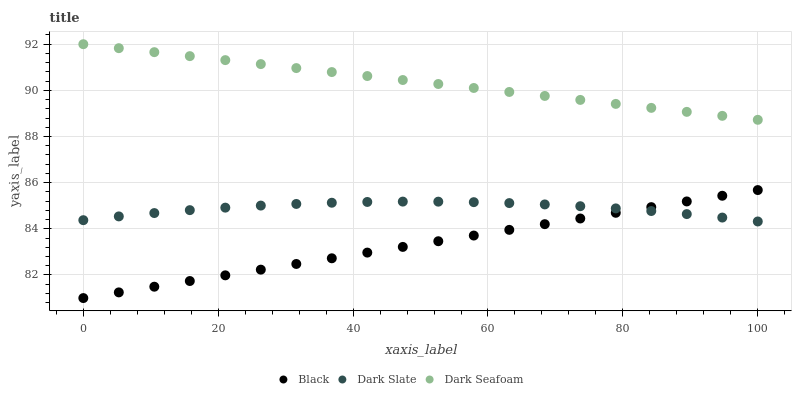Does Black have the minimum area under the curve?
Answer yes or no. Yes. Does Dark Seafoam have the maximum area under the curve?
Answer yes or no. Yes. Does Dark Seafoam have the minimum area under the curve?
Answer yes or no. No. Does Black have the maximum area under the curve?
Answer yes or no. No. Is Dark Seafoam the smoothest?
Answer yes or no. Yes. Is Dark Slate the roughest?
Answer yes or no. Yes. Is Black the smoothest?
Answer yes or no. No. Is Black the roughest?
Answer yes or no. No. Does Black have the lowest value?
Answer yes or no. Yes. Does Dark Seafoam have the lowest value?
Answer yes or no. No. Does Dark Seafoam have the highest value?
Answer yes or no. Yes. Does Black have the highest value?
Answer yes or no. No. Is Dark Slate less than Dark Seafoam?
Answer yes or no. Yes. Is Dark Seafoam greater than Black?
Answer yes or no. Yes. Does Black intersect Dark Slate?
Answer yes or no. Yes. Is Black less than Dark Slate?
Answer yes or no. No. Is Black greater than Dark Slate?
Answer yes or no. No. Does Dark Slate intersect Dark Seafoam?
Answer yes or no. No. 